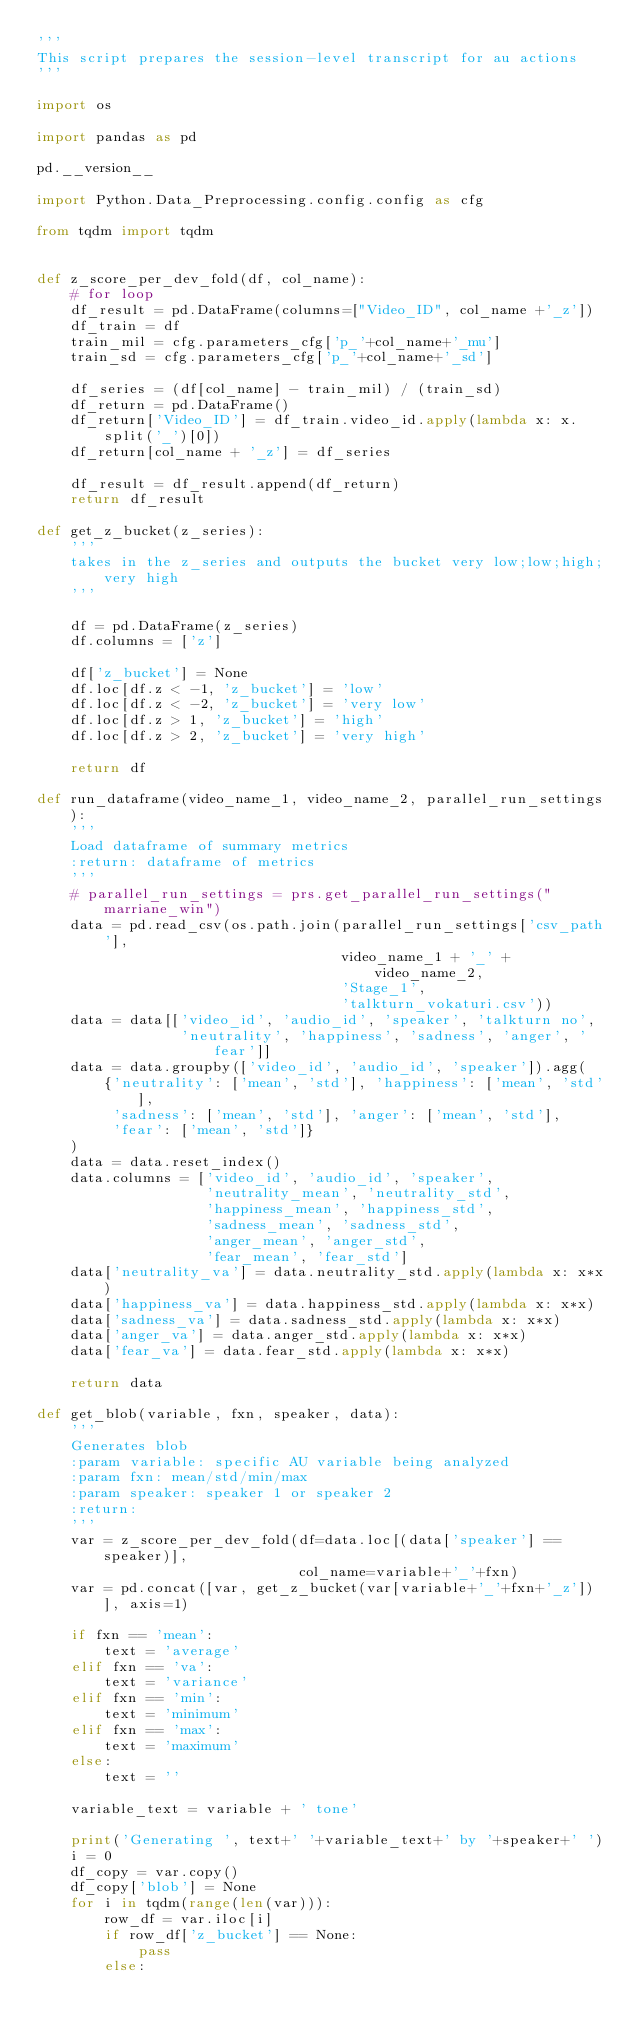<code> <loc_0><loc_0><loc_500><loc_500><_Python_>'''
This script prepares the session-level transcript for au actions
'''

import os

import pandas as pd

pd.__version__

import Python.Data_Preprocessing.config.config as cfg

from tqdm import tqdm


def z_score_per_dev_fold(df, col_name):
    # for loop
    df_result = pd.DataFrame(columns=["Video_ID", col_name +'_z'])
    df_train = df
    train_mil = cfg.parameters_cfg['p_'+col_name+'_mu']
    train_sd = cfg.parameters_cfg['p_'+col_name+'_sd']

    df_series = (df[col_name] - train_mil) / (train_sd)
    df_return = pd.DataFrame()
    df_return['Video_ID'] = df_train.video_id.apply(lambda x: x.split('_')[0])
    df_return[col_name + '_z'] = df_series

    df_result = df_result.append(df_return)
    return df_result

def get_z_bucket(z_series):
    '''
    takes in the z_series and outputs the bucket very low;low;high;very high
    '''

    df = pd.DataFrame(z_series)
    df.columns = ['z']

    df['z_bucket'] = None
    df.loc[df.z < -1, 'z_bucket'] = 'low'
    df.loc[df.z < -2, 'z_bucket'] = 'very low'
    df.loc[df.z > 1, 'z_bucket'] = 'high'
    df.loc[df.z > 2, 'z_bucket'] = 'very high'

    return df

def run_dataframe(video_name_1, video_name_2, parallel_run_settings):
    '''
    Load dataframe of summary metrics
    :return: dataframe of metrics
    '''
    # parallel_run_settings = prs.get_parallel_run_settings("marriane_win")
    data = pd.read_csv(os.path.join(parallel_run_settings['csv_path'],
                                    video_name_1 + '_' + video_name_2,
                                    'Stage_1',
                                    'talkturn_vokaturi.csv'))
    data = data[['video_id', 'audio_id', 'speaker', 'talkturn no',
                 'neutrality', 'happiness', 'sadness', 'anger', 'fear']]
    data = data.groupby(['video_id', 'audio_id', 'speaker']).agg(
        {'neutrality': ['mean', 'std'], 'happiness': ['mean', 'std'],
         'sadness': ['mean', 'std'], 'anger': ['mean', 'std'],
         'fear': ['mean', 'std']}
    )
    data = data.reset_index()
    data.columns = ['video_id', 'audio_id', 'speaker',
                    'neutrality_mean', 'neutrality_std',
                    'happiness_mean', 'happiness_std',
                    'sadness_mean', 'sadness_std',
                    'anger_mean', 'anger_std',
                    'fear_mean', 'fear_std']
    data['neutrality_va'] = data.neutrality_std.apply(lambda x: x*x)
    data['happiness_va'] = data.happiness_std.apply(lambda x: x*x)
    data['sadness_va'] = data.sadness_std.apply(lambda x: x*x)
    data['anger_va'] = data.anger_std.apply(lambda x: x*x)
    data['fear_va'] = data.fear_std.apply(lambda x: x*x)

    return data

def get_blob(variable, fxn, speaker, data):
    '''
    Generates blob
    :param variable: specific AU variable being analyzed
    :param fxn: mean/std/min/max
    :param speaker: speaker 1 or speaker 2
    :return:
    '''
    var = z_score_per_dev_fold(df=data.loc[(data['speaker'] == speaker)],
                               col_name=variable+'_'+fxn)
    var = pd.concat([var, get_z_bucket(var[variable+'_'+fxn+'_z'])], axis=1)

    if fxn == 'mean':
        text = 'average'
    elif fxn == 'va':
        text = 'variance'
    elif fxn == 'min':
        text = 'minimum'
    elif fxn == 'max':
        text = 'maximum'
    else:
        text = ''

    variable_text = variable + ' tone'

    print('Generating ', text+' '+variable_text+' by '+speaker+' ')
    i = 0
    df_copy = var.copy()
    df_copy['blob'] = None
    for i in tqdm(range(len(var))):
        row_df = var.iloc[i]
        if row_df['z_bucket'] == None:
            pass
        else:</code> 